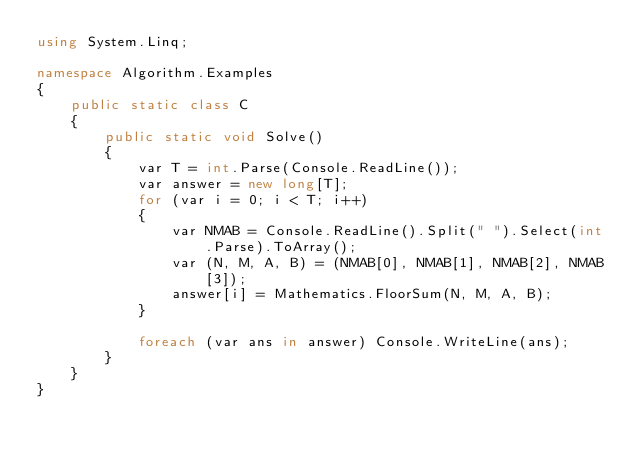Convert code to text. <code><loc_0><loc_0><loc_500><loc_500><_C#_>using System.Linq;

namespace Algorithm.Examples
{
    public static class C
    {
        public static void Solve()
        {
            var T = int.Parse(Console.ReadLine());
            var answer = new long[T];
            for (var i = 0; i < T; i++)
            {
                var NMAB = Console.ReadLine().Split(" ").Select(int.Parse).ToArray();
                var (N, M, A, B) = (NMAB[0], NMAB[1], NMAB[2], NMAB[3]);
                answer[i] = Mathematics.FloorSum(N, M, A, B);
            }

            foreach (var ans in answer) Console.WriteLine(ans);
        }
    }
}</code> 